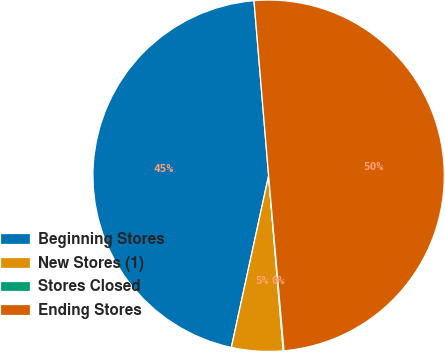<chart> <loc_0><loc_0><loc_500><loc_500><pie_chart><fcel>Beginning Stores<fcel>New Stores (1)<fcel>Stores Closed<fcel>Ending Stores<nl><fcel>45.27%<fcel>4.73%<fcel>0.07%<fcel>49.93%<nl></chart> 